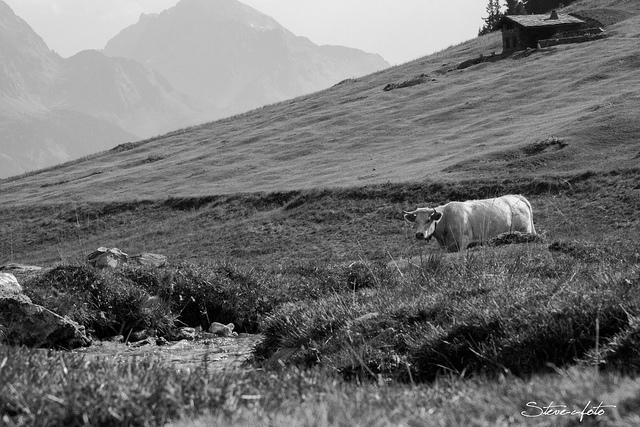How many cows in the picture?
Be succinct. 1. How many legs does the animal have?
Be succinct. 4. What is on top of the house?
Keep it brief. Chimney. What is far in the background?
Concise answer only. House. How many cow are white?
Give a very brief answer. 1. 